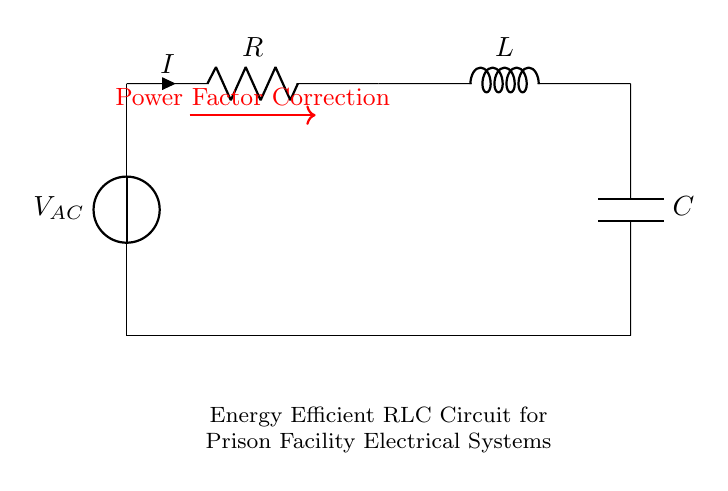What is the function of the component labeled R? The component labeled R is a resistor, which limits the current and dissipates energy as heat, aiding in power factor correction.
Answer: Resistor What is the component L used for in this circuit? The component L is an inductor, which stores energy in a magnetic field and can react to changes in current, playing a role in power factor correction.
Answer: Inductor What is the primary purpose of this RLC circuit? The primary purpose of this RLC circuit is to provide power factor correction, improving energy efficiency in electrical systems.
Answer: Power Factor Correction What is connected to the voltage source in this circuit? The voltage source is connected to the resistor, which is then connected to the inductor and capacitor in series, forming the circuit path.
Answer: Resistor How many energy storage elements are present in this RLC circuit? There are two energy storage elements present: one inductor and one capacitor, each serving their specific function in storing energy.
Answer: Two What effect does proper power factor correction have on a prison facility's electrical systems? Proper power factor correction reduces energy losses, decreases utility charges, and enhances overall efficiency, which is particularly beneficial for the prison facility's operating costs.
Answer: Efficiency What is the relationship between the resistor, inductor, and capacitor in terms of energy? The resistor dissipates energy, while the inductor and capacitor store energy, creating a balance necessary for efficient power factor correction in the circuit.
Answer: Balance 